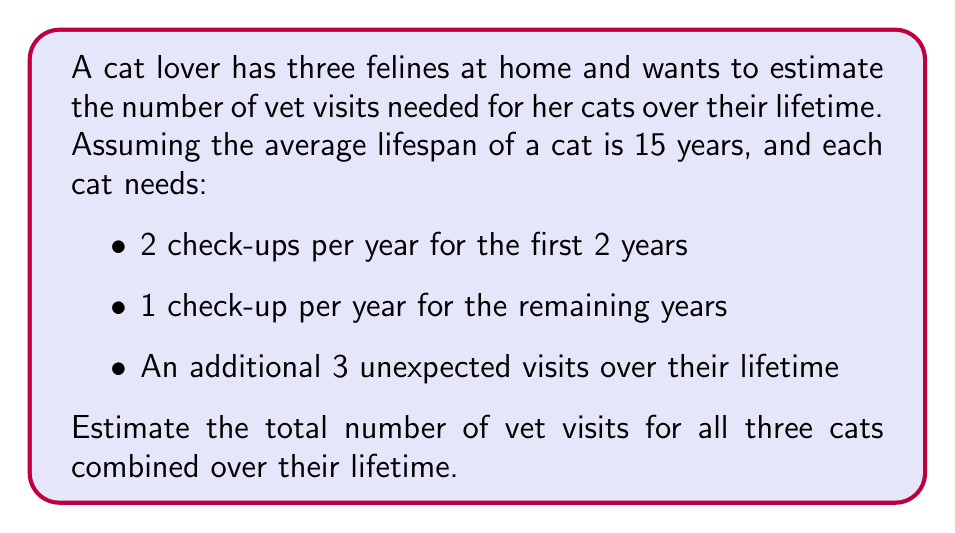Can you solve this math problem? Let's break this down step-by-step:

1. Calculate regular check-ups for one cat:
   - First 2 years: $2 \text{ years} \times 2 \text{ visits/year} = 4 \text{ visits}$
   - Remaining years: $13 \text{ years} \times 1 \text{ visit/year} = 13 \text{ visits}$
   - Total regular check-ups: $4 + 13 = 17 \text{ visits}$

2. Add unexpected visits for one cat:
   - Total visits for one cat = Regular check-ups + Unexpected visits
   - $17 + 3 = 20 \text{ visits}$

3. Calculate total visits for all three cats:
   - $\text{Total visits} = 3 \text{ cats} \times 20 \text{ visits/cat}$
   - $\text{Total visits} = 60 \text{ visits}$

Therefore, the estimated number of vet visits for all three cats over their lifetime is 60 visits.
Answer: $60 \text{ visits}$ 